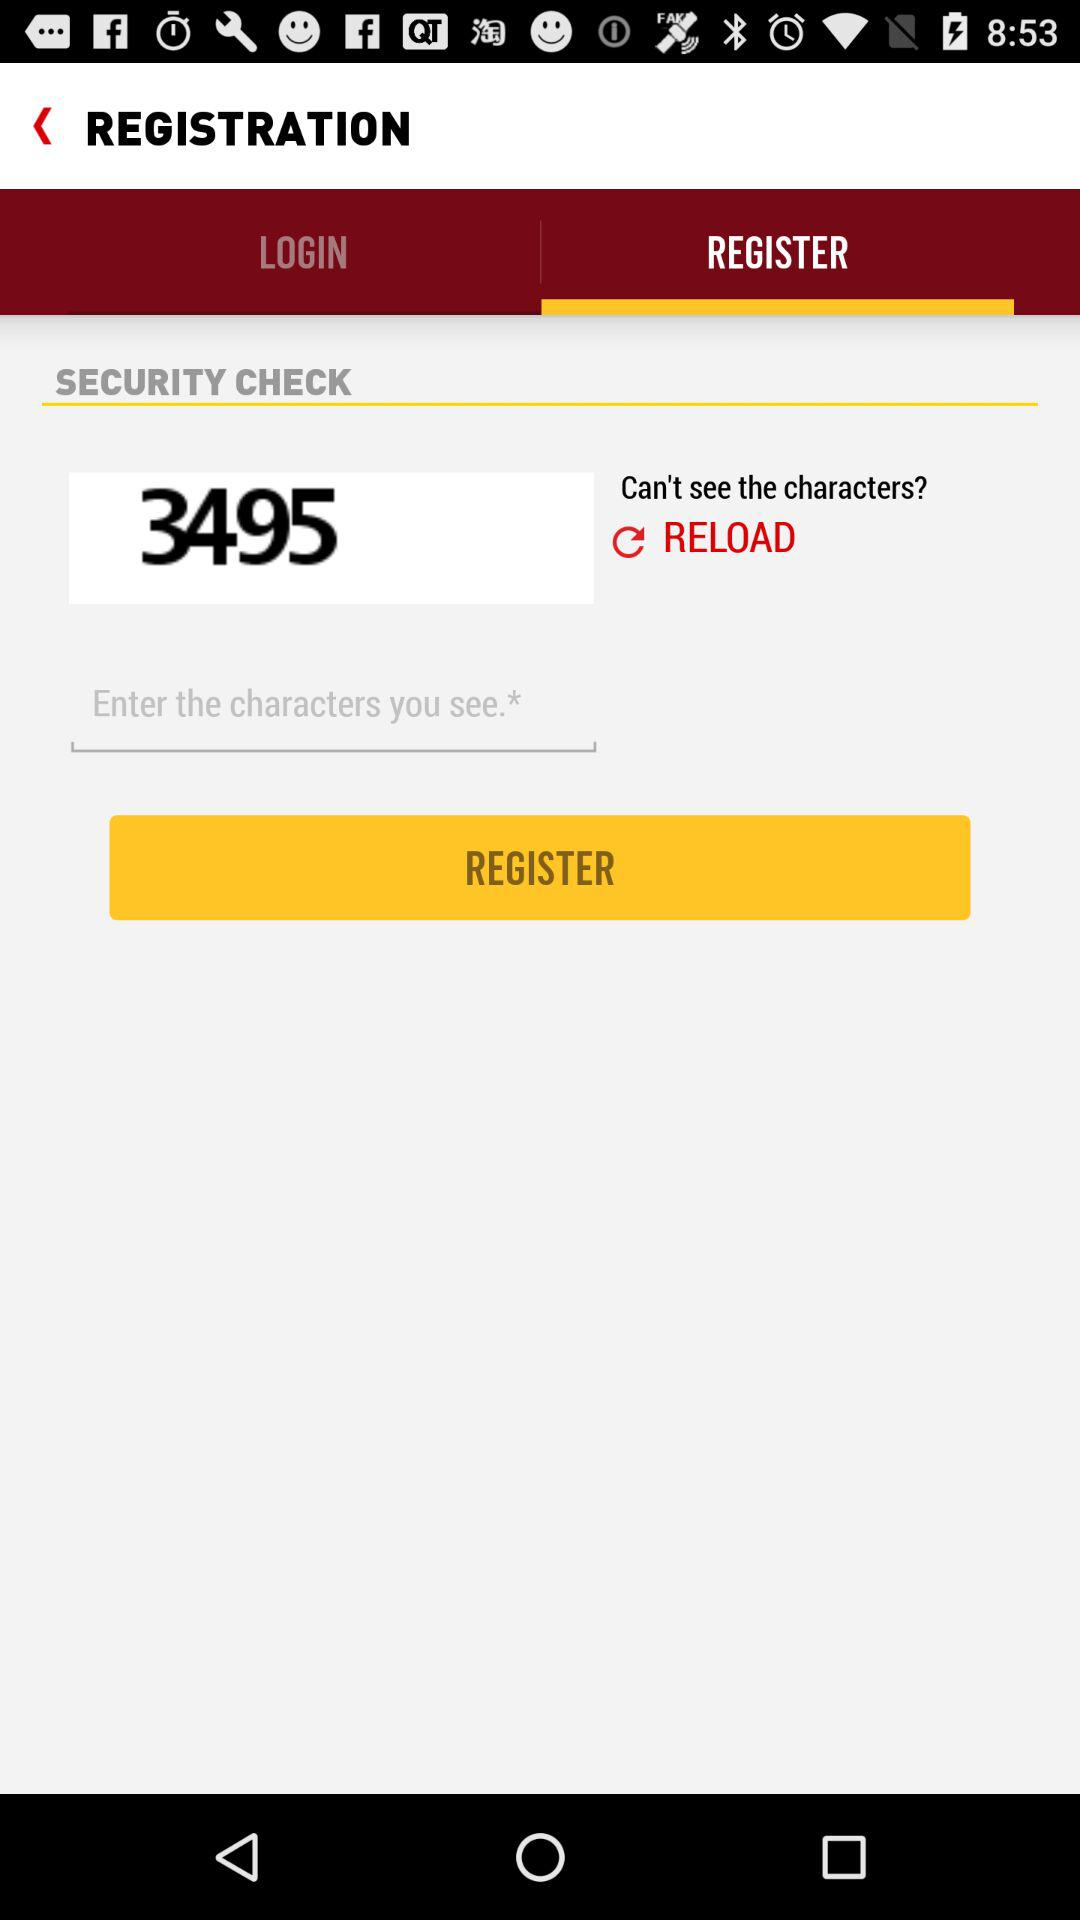What is the security check code? The security check code is 3495. 